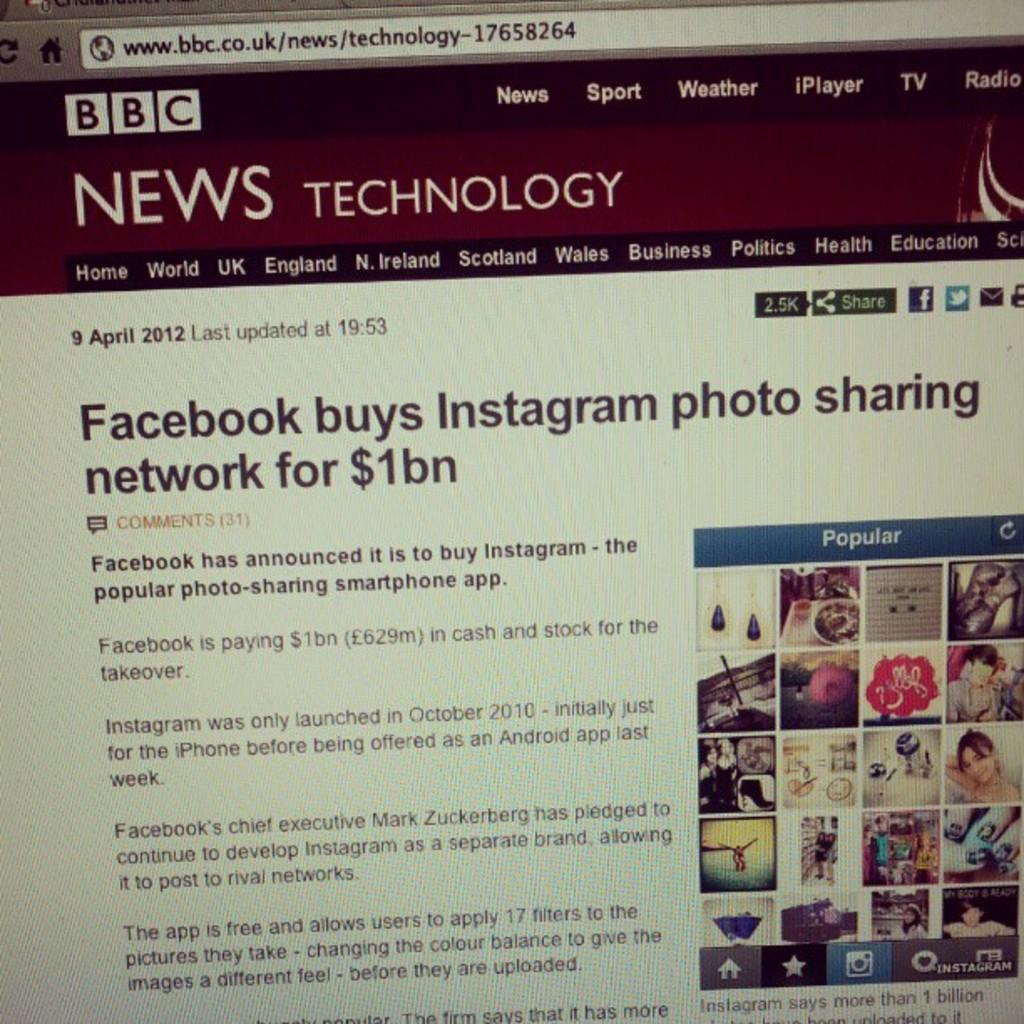<image>
Give a short and clear explanation of the subsequent image. The story on the computer is about Facebook buying Instagram. 